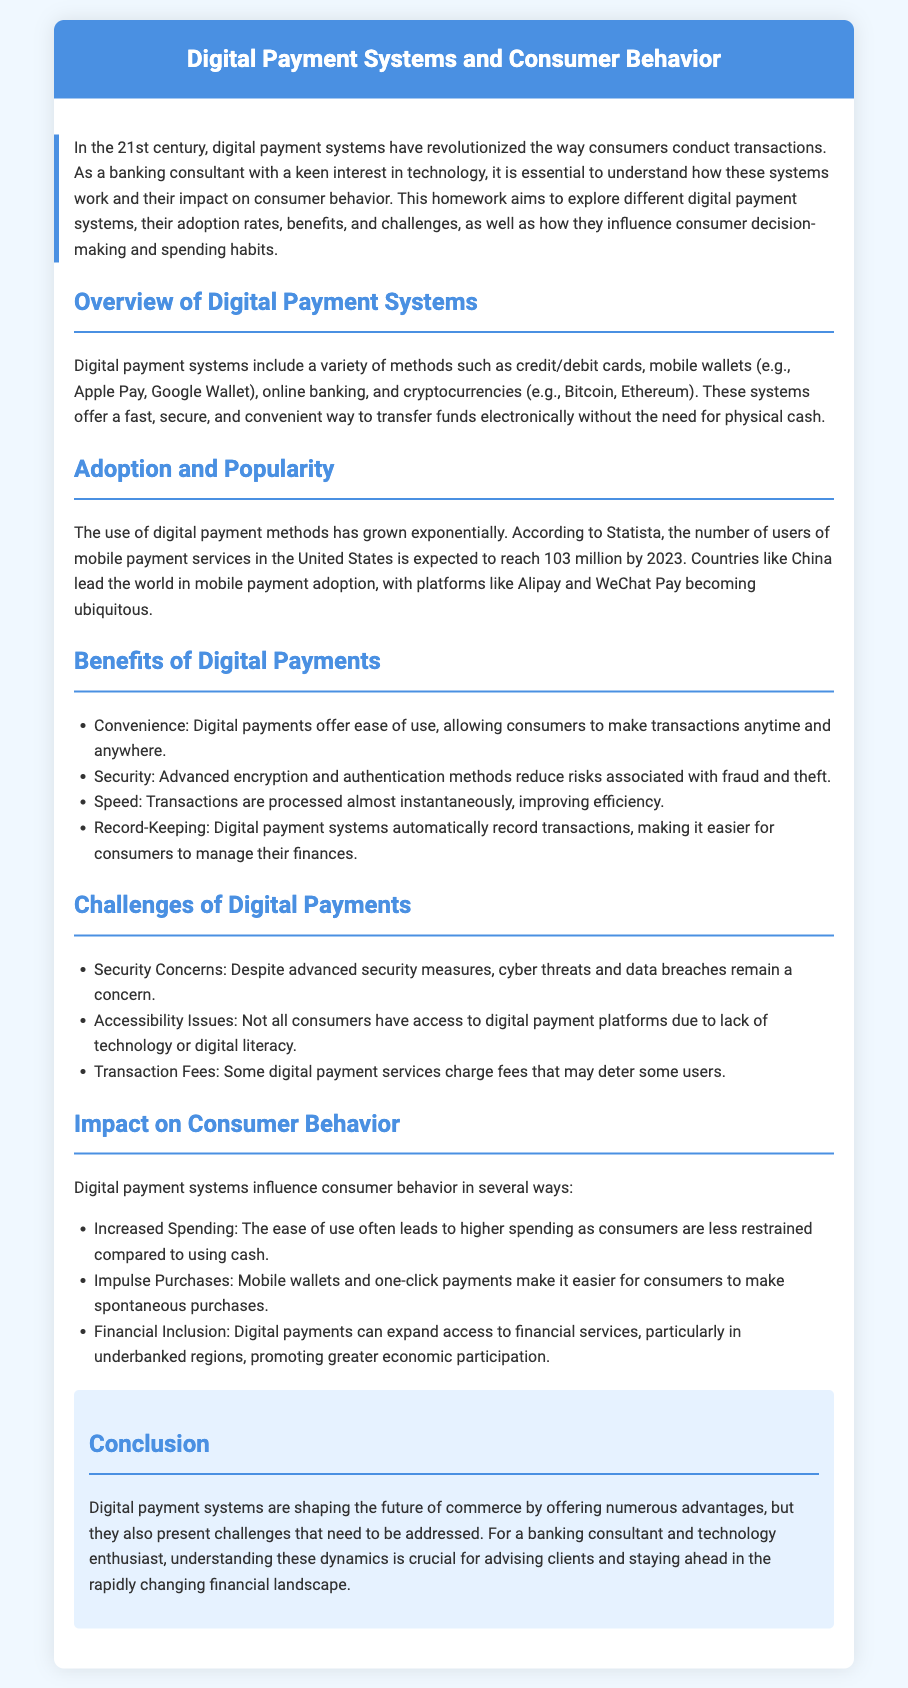What are the types of digital payment systems mentioned? The types of digital payment systems listed in the document include credit/debit cards, mobile wallets, online banking, and cryptocurrencies.
Answer: credit/debit cards, mobile wallets, online banking, cryptocurrencies What is the expected number of mobile payment users in the US by 2023? According to Statista, the expected number of mobile payment users in the United States by 2023 is 103 million.
Answer: 103 million What two platforms are mentioned as leading mobile payment services in China? The document mentions Alipay and WeChat Pay as the leading mobile payment platforms in China.
Answer: Alipay, WeChat Pay What is one key benefit of digital payments listed? The document cites convenience as one of the key benefits of digital payments, allowing transactions anytime and anywhere.
Answer: Convenience What challenge is related to security for digital payment systems? The document mentions security concerns as a challenge for digital payment systems due to cyber threats and data breaches.
Answer: Security concerns How do digital payment systems influence spending habits? The document indicates that digital payment systems lead to increased spending as consumers feel less restrained compared to using cash.
Answer: Increased spending What is one impact of digital payments on financial inclusion? The document states that digital payments can expand access to financial services, particularly in underbanked regions.
Answer: Expand access to financial services What is a characteristic of the document's structure? The document is structured with sections that include headings and a conclusion, making it easy to navigate and understand the content.
Answer: Sections with headings and a conclusion 